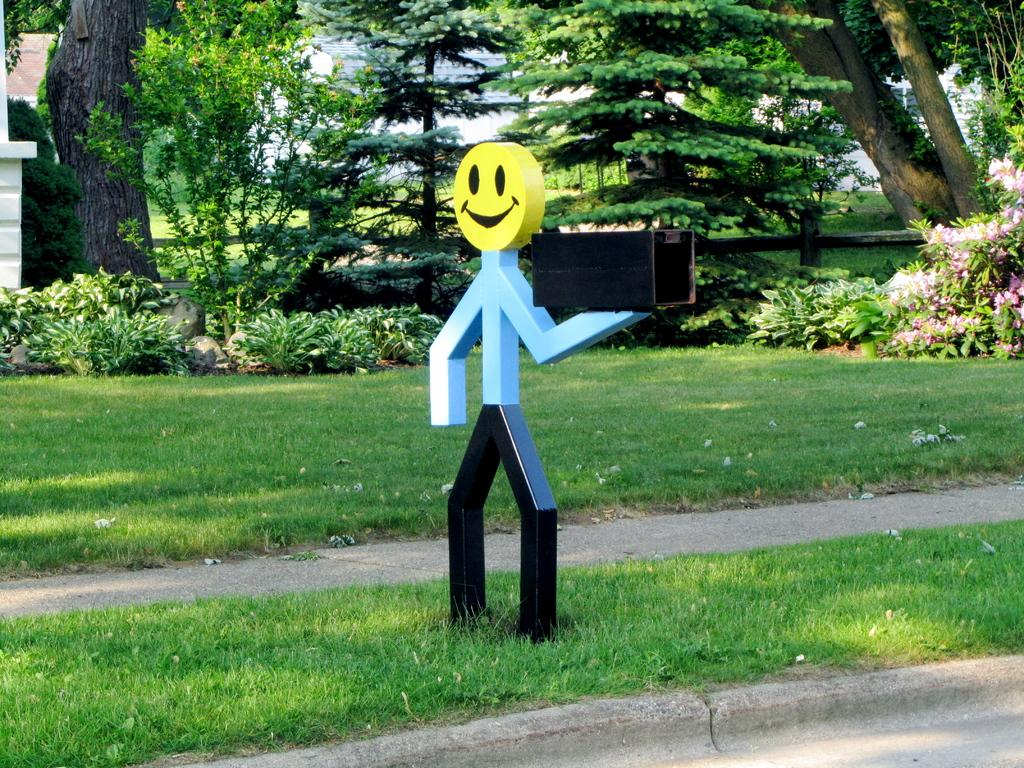What is depicted on the poster in the image? There is a symbol of a man with a smiley face in the image, and it is on a poster. Where is the poster located? The poster is on the grass in the image. What can be seen in the middle of the grass? There is a path in the middle of the grass. What is visible in the background of the image? Trees, a house, and flowers are visible in the background of the image. Can you see the ocean in the background of the image? No, there is no ocean visible in the background of the image. Is there a fire burning near the poster? No, there is no fire present in the image. 